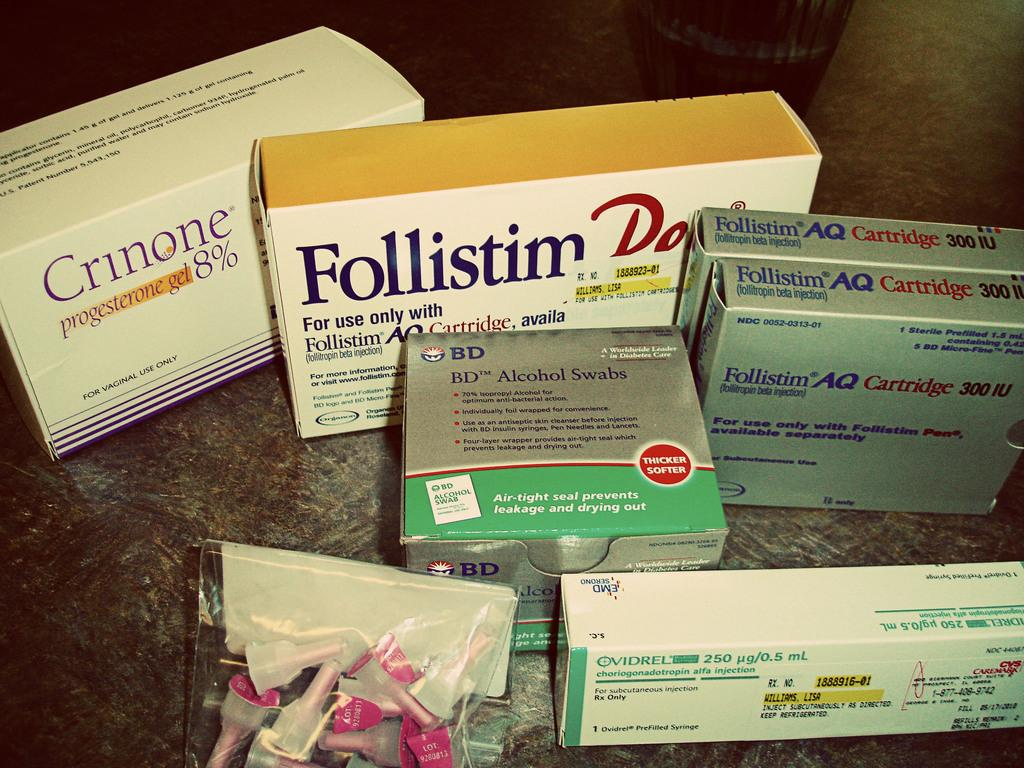<image>
Describe the image concisely. Several prescriptions sit on a countertop including "Crinone 8%". 